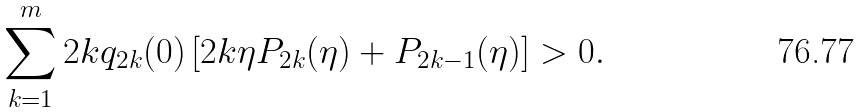Convert formula to latex. <formula><loc_0><loc_0><loc_500><loc_500>\sum _ { k = 1 } ^ { m } 2 k q _ { 2 k } ( 0 ) \left [ 2 k \eta P _ { 2 k } ( \eta ) + P _ { 2 k - 1 } ( \eta ) \right ] > 0 .</formula> 